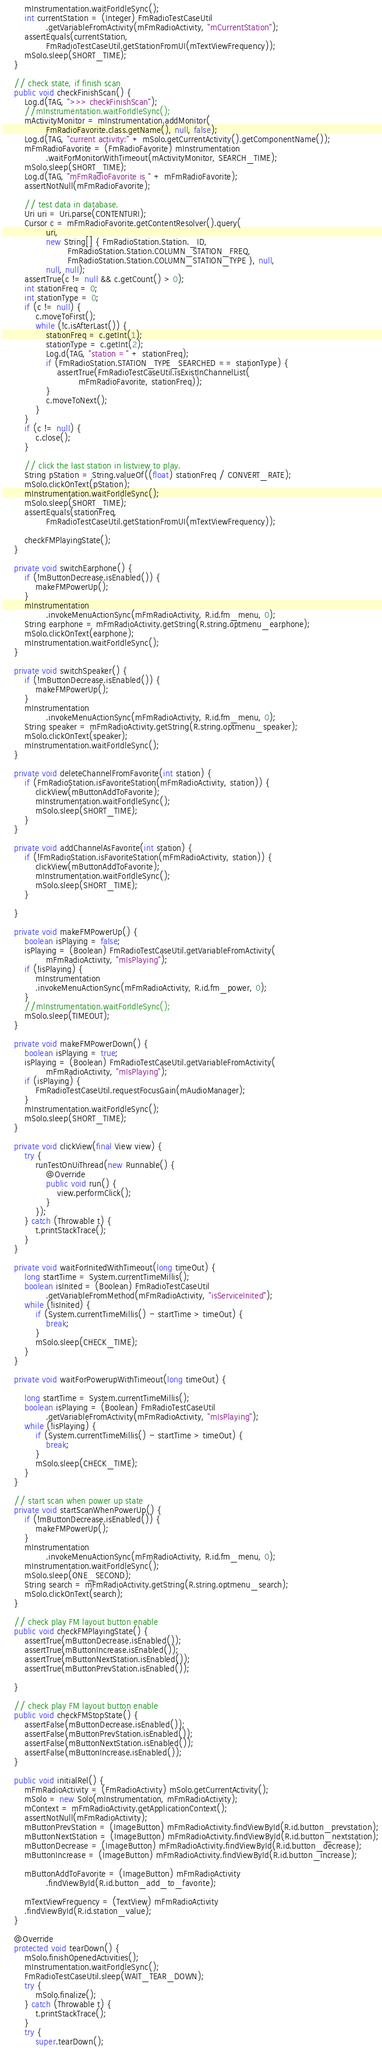Convert code to text. <code><loc_0><loc_0><loc_500><loc_500><_Java_>        mInstrumentation.waitForIdleSync();
        int currentStation = (Integer) FmRadioTestCaseUtil
                .getVariableFromActivity(mFmRadioActivity, "mCurrentStation");
        assertEquals(currentStation,
                FmRadioTestCaseUtil.getStationFromUI(mTextViewFrequency));
        mSolo.sleep(SHORT_TIME);
    }

    // check state, if finish scan
    public void checkFinishScan() {
        Log.d(TAG, ">>> checkFinishScan");
        //mInstrumentation.waitForIdleSync();
        mActivityMonitor = mInstrumentation.addMonitor(
                FmRadioFavorite.class.getName(), null, false);
        Log.d(TAG, "current activity:" + mSolo.getCurrentActivity().getComponentName());
        mFmRadioFavorite = (FmRadioFavorite) mInstrumentation
                .waitForMonitorWithTimeout(mActivityMonitor, SEARCH_TIME);
        mSolo.sleep(SHORT_TIME);
        Log.d(TAG, "mFmRadioFavorite is " + mFmRadioFavorite);
        assertNotNull(mFmRadioFavorite);

        // test data in database.
        Uri uri = Uri.parse(CONTENTURI);
        Cursor c = mFmRadioFavorite.getContentResolver().query(
                uri,
                new String[] { FmRadioStation.Station._ID,
                        FmRadioStation.Station.COLUMN_STATION_FREQ,
                        FmRadioStation.Station.COLUMN_STATION_TYPE }, null,
                null, null);
        assertTrue(c != null && c.getCount() > 0);
        int stationFreq = 0;
        int stationType = 0;
        if (c != null) {
            c.moveToFirst();
            while (!c.isAfterLast()) {
                stationFreq = c.getInt(1);
                stationType = c.getInt(2);
                Log.d(TAG, "station =" + stationFreq);
                if (FmRadioStation.STATION_TYPE_SEARCHED == stationType) {
                    assertTrue(FmRadioTestCaseUtil.isExistInChannelList(
                            mFmRadioFavorite, stationFreq));
                }
                c.moveToNext();
            }
        }
        if (c != null) {
            c.close();
        }

        // click the last station in listview to play.
        String pStation = String.valueOf((float) stationFreq / CONVERT_RATE);
        mSolo.clickOnText(pStation);
        mInstrumentation.waitForIdleSync();
        mSolo.sleep(SHORT_TIME);
        assertEquals(stationFreq,
                FmRadioTestCaseUtil.getStationFromUI(mTextViewFrequency));

        checkFMPlayingState();
    }

    private void switchEarphone() {
        if (!mButtonDecrease.isEnabled()) {
            makeFMPowerUp();
        }
        mInstrumentation
                .invokeMenuActionSync(mFmRadioActivity, R.id.fm_menu, 0);
        String earphone = mFmRadioActivity.getString(R.string.optmenu_earphone);
        mSolo.clickOnText(earphone);
        mInstrumentation.waitForIdleSync();
    }

    private void switchSpeaker() {
        if (!mButtonDecrease.isEnabled()) {
            makeFMPowerUp();
        }
        mInstrumentation
                .invokeMenuActionSync(mFmRadioActivity, R.id.fm_menu, 0);
        String speaker = mFmRadioActivity.getString(R.string.optmenu_speaker);
        mSolo.clickOnText(speaker);
        mInstrumentation.waitForIdleSync();
    }

    private void deleteChannelFromFavorite(int station) {
        if (FmRadioStation.isFavoriteStation(mFmRadioActivity, station)) {
            clickView(mButtonAddToFavorite);
            mInstrumentation.waitForIdleSync();
            mSolo.sleep(SHORT_TIME);
        }
    }

    private void addChannelAsFavorite(int station) {
        if (!FmRadioStation.isFavoriteStation(mFmRadioActivity, station)) {
            clickView(mButtonAddToFavorite);
            mInstrumentation.waitForIdleSync();
            mSolo.sleep(SHORT_TIME);
        }

    }

    private void makeFMPowerUp() {
        boolean isPlaying = false;
        isPlaying = (Boolean) FmRadioTestCaseUtil.getVariableFromActivity(
                mFmRadioActivity, "mIsPlaying");
        if (!isPlaying) {
            mInstrumentation
            .invokeMenuActionSync(mFmRadioActivity, R.id.fm_power, 0);
        }
        //mInstrumentation.waitForIdleSync();
        mSolo.sleep(TIMEOUT);
    }

    private void makeFMPowerDown() {
        boolean isPlaying = true;
        isPlaying = (Boolean) FmRadioTestCaseUtil.getVariableFromActivity(
                mFmRadioActivity, "mIsPlaying");
        if (isPlaying) {
            FmRadioTestCaseUtil.requestFocusGain(mAudioManager);
        }
        mInstrumentation.waitForIdleSync();
        mSolo.sleep(SHORT_TIME);
    }

    private void clickView(final View view) {
        try {
            runTestOnUiThread(new Runnable() {
                @Override
                public void run() {
                    view.performClick();
                }
            });
        } catch (Throwable t) {
            t.printStackTrace();
        }
    }

    private void waitForInitedWithTimeout(long timeOut) {
        long startTime = System.currentTimeMillis();
        boolean isInited = (Boolean) FmRadioTestCaseUtil
                .getVariableFromMethod(mFmRadioActivity, "isServiceInited");
        while (!isInited) {
            if (System.currentTimeMillis() - startTime > timeOut) {
                break;
            }
            mSolo.sleep(CHECK_TIME);
        }
    }

    private void waitForPowerupWithTimeout(long timeOut) {

        long startTime = System.currentTimeMillis();
        boolean isPlaying = (Boolean) FmRadioTestCaseUtil
                .getVariableFromActivity(mFmRadioActivity, "mIsPlaying");
        while (!isPlaying) {
            if (System.currentTimeMillis() - startTime > timeOut) {
                break;
            }
            mSolo.sleep(CHECK_TIME);
        }
    }

    // start scan when power up state
    private void startScanWhenPowerUp() {
        if (!mButtonDecrease.isEnabled()) {
            makeFMPowerUp();
        }
        mInstrumentation
                .invokeMenuActionSync(mFmRadioActivity, R.id.fm_menu, 0);
        mInstrumentation.waitForIdleSync();
        mSolo.sleep(ONE_SECOND);
        String search = mFmRadioActivity.getString(R.string.optmenu_search);
        mSolo.clickOnText(search);
    }

    // check play FM layout button enable
    public void checkFMPlayingState() {
        assertTrue(mButtonDecrease.isEnabled());
        assertTrue(mButtonIncrease.isEnabled());
        assertTrue(mButtonNextStation.isEnabled());
        assertTrue(mButtonPrevStation.isEnabled());

    }

    // check play FM layout button enable
    public void checkFMStopState() {
        assertFalse(mButtonDecrease.isEnabled());
        assertFalse(mButtonPrevStation.isEnabled());
        assertFalse(mButtonNextStation.isEnabled());
        assertFalse(mButtonIncrease.isEnabled());
    }

    public void initialRel() {
        mFmRadioActivity = (FmRadioActivity) mSolo.getCurrentActivity();
        mSolo = new Solo(mInstrumentation, mFmRadioActivity);
        mContext = mFmRadioActivity.getApplicationContext();
        assertNotNull(mFmRadioActivity);
        mButtonPrevStation = (ImageButton) mFmRadioActivity.findViewById(R.id.button_prevstation);
        mButtonNextStation = (ImageButton) mFmRadioActivity.findViewById(R.id.button_nextstation);
        mButtonDecrease = (ImageButton) mFmRadioActivity.findViewById(R.id.button_decrease);
        mButtonIncrease = (ImageButton) mFmRadioActivity.findViewById(R.id.button_increase);

        mButtonAddToFavorite = (ImageButton) mFmRadioActivity
                .findViewById(R.id.button_add_to_favorite);

        mTextViewFrequency = (TextView) mFmRadioActivity
        .findViewById(R.id.station_value);
    }

    @Override
    protected void tearDown() {
        mSolo.finishOpenedActivities();
        mInstrumentation.waitForIdleSync();
        FmRadioTestCaseUtil.sleep(WAIT_TEAR_DOWN);
        try {
            mSolo.finalize();
        } catch (Throwable t) {
            t.printStackTrace();
        }
        try {
            super.tearDown();</code> 